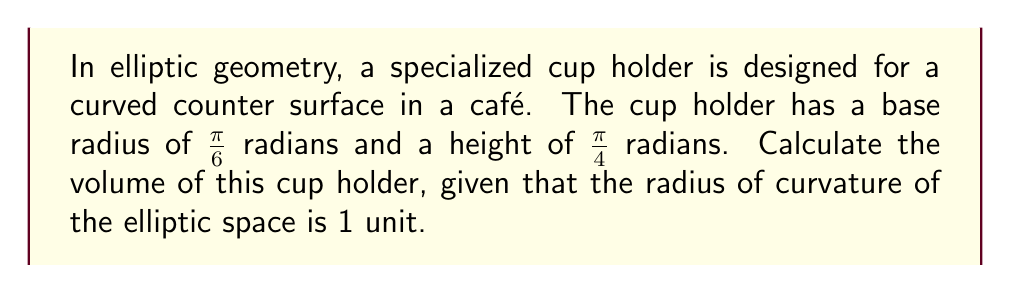Show me your answer to this math problem. To calculate the volume of the specialized cup holder in elliptic geometry, we'll follow these steps:

1. In elliptic geometry, the volume of a cylinder is given by:
   $$V = 2\pi(\sin r - r \cos r)h$$
   where $r$ is the base radius, $h$ is the height, and the radius of curvature is 1.

2. We're given:
   Base radius, $r = \frac{\pi}{6}$ radians
   Height, $h = \frac{\pi}{4}$ radians

3. Substitute these values into the volume formula:
   $$V = 2\pi(\sin \frac{\pi}{6} - \frac{\pi}{6} \cos \frac{\pi}{6}) \cdot \frac{\pi}{4}$$

4. Evaluate trigonometric functions:
   $$\sin \frac{\pi}{6} = \frac{1}{2}$$
   $$\cos \frac{\pi}{6} = \frac{\sqrt{3}}{2}$$

5. Substitute these values:
   $$V = 2\pi(\frac{1}{2} - \frac{\pi}{6} \cdot \frac{\sqrt{3}}{2}) \cdot \frac{\pi}{4}$$

6. Simplify:
   $$V = \frac{\pi^2}{2}(1 - \frac{\pi\sqrt{3}}{6})$$

7. Approximate the final value:
   $$V \approx 1.089$$

The volume is approximately 1.089 cubic units in the elliptic space.
Answer: $\frac{\pi^2}{2}(1 - \frac{\pi\sqrt{3}}{6}) \approx 1.089$ cubic units 